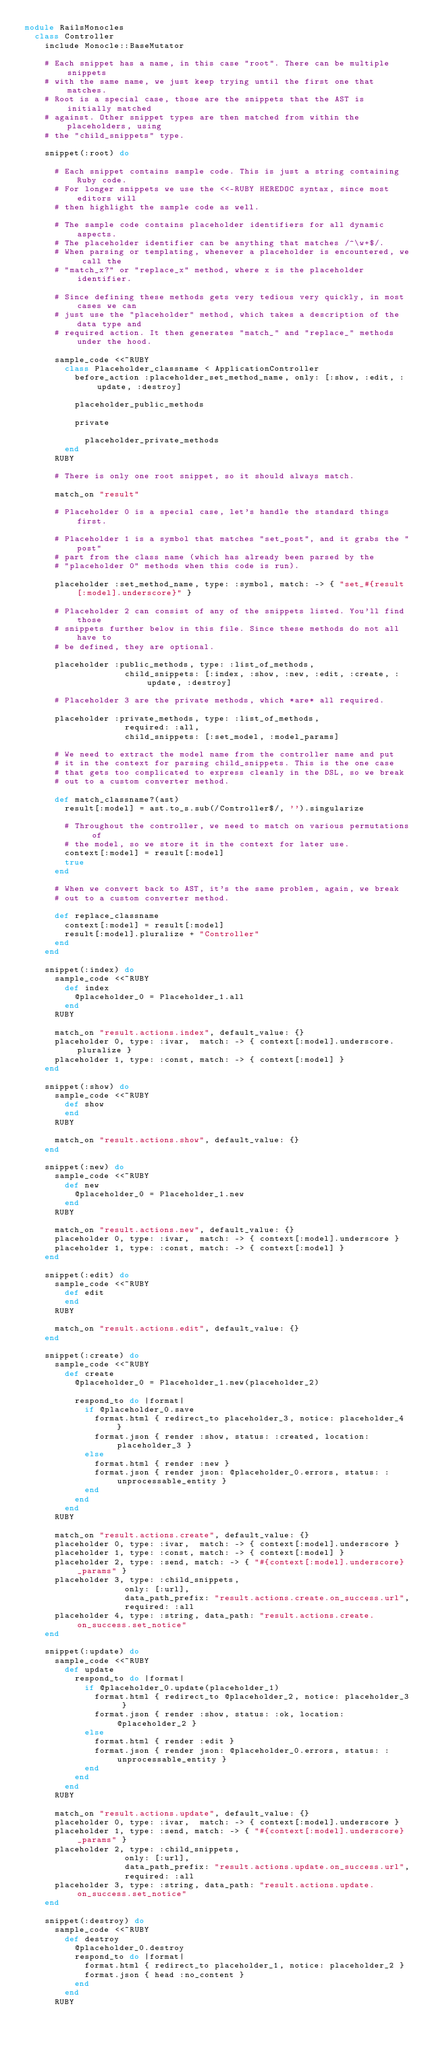<code> <loc_0><loc_0><loc_500><loc_500><_Ruby_>module RailsMonocles
  class Controller
    include Monocle::BaseMutator

    # Each snippet has a name, in this case "root". There can be multiple snippets
    # with the same name, we just keep trying until the first one that matches.
    # Root is a special case, those are the snippets that the AST is initially matched
    # against. Other snippet types are then matched from within the placeholders, using
    # the "child_snippets" type.

    snippet(:root) do

      # Each snippet contains sample code. This is just a string containing Ruby code.
      # For longer snippets we use the <<-RUBY HEREDOC syntax, since most editors will
      # then highlight the sample code as well.

      # The sample code contains placeholder identifiers for all dynamic aspects.
      # The placeholder identifier can be anything that matches /^\w+$/.
      # When parsing or templating, whenever a placeholder is encountered, we call the
      # "match_x?" or "replace_x" method, where x is the placeholder identifier.

      # Since defining these methods gets very tedious very quickly, in most cases we can
      # just use the "placeholder" method, which takes a description of the data type and
      # required action. It then generates "match_" and "replace_" methods under the hood.

      sample_code <<~RUBY
        class Placeholder_classname < ApplicationController
          before_action :placeholder_set_method_name, only: [:show, :edit, :update, :destroy]

          placeholder_public_methods

          private

            placeholder_private_methods
        end
      RUBY

      # There is only one root snippet, so it should always match.

      match_on "result"

      # Placeholder 0 is a special case, let's handle the standard things first.

      # Placeholder 1 is a symbol that matches "set_post", and it grabs the "post"
      # part from the class name (which has already been parsed by the
      # "placeholder 0" methods when this code is run).

      placeholder :set_method_name, type: :symbol, match: -> { "set_#{result[:model].underscore}" }

      # Placeholder 2 can consist of any of the snippets listed. You'll find those
      # snippets further below in this file. Since these methods do not all have to
      # be defined, they are optional.

      placeholder :public_methods, type: :list_of_methods,
                    child_snippets: [:index, :show, :new, :edit, :create, :update, :destroy]

      # Placeholder 3 are the private methods, which *are* all required.

      placeholder :private_methods, type: :list_of_methods,
                    required: :all,
                    child_snippets: [:set_model, :model_params]

      # We need to extract the model name from the controller name and put
      # it in the context for parsing child_snippets. This is the one case
      # that gets too complicated to express cleanly in the DSL, so we break
      # out to a custom converter method.

      def match_classname?(ast)
        result[:model] = ast.to_s.sub(/Controller$/, '').singularize

        # Throughout the controller, we need to match on various permutations of
        # the model, so we store it in the context for later use.
        context[:model] = result[:model]
        true
      end

      # When we convert back to AST, it's the same problem, again, we break
      # out to a custom converter method.

      def replace_classname
        context[:model] = result[:model]
        result[:model].pluralize + "Controller"
      end
    end

    snippet(:index) do
      sample_code <<~RUBY
        def index
          @placeholder_0 = Placeholder_1.all
        end
      RUBY

      match_on "result.actions.index", default_value: {}
      placeholder 0, type: :ivar,  match: -> { context[:model].underscore.pluralize }
      placeholder 1, type: :const, match: -> { context[:model] }
    end

    snippet(:show) do
      sample_code <<~RUBY
        def show
        end
      RUBY

      match_on "result.actions.show", default_value: {}
    end

    snippet(:new) do
      sample_code <<~RUBY
        def new
          @placeholder_0 = Placeholder_1.new
        end
      RUBY

      match_on "result.actions.new", default_value: {}
      placeholder 0, type: :ivar,  match: -> { context[:model].underscore }
      placeholder 1, type: :const, match: -> { context[:model] }
    end

    snippet(:edit) do
      sample_code <<~RUBY
        def edit
        end
      RUBY

      match_on "result.actions.edit", default_value: {}
    end

    snippet(:create) do
      sample_code <<~RUBY
        def create
          @placeholder_0 = Placeholder_1.new(placeholder_2)

          respond_to do |format|
            if @placeholder_0.save
              format.html { redirect_to placeholder_3, notice: placeholder_4 }
              format.json { render :show, status: :created, location: placeholder_3 }
            else
              format.html { render :new }
              format.json { render json: @placeholder_0.errors, status: :unprocessable_entity }
            end
          end
        end
      RUBY

      match_on "result.actions.create", default_value: {}
      placeholder 0, type: :ivar,  match: -> { context[:model].underscore }
      placeholder 1, type: :const, match: -> { context[:model] }
      placeholder 2, type: :send, match: -> { "#{context[:model].underscore}_params" }
      placeholder 3, type: :child_snippets,
                    only: [:url],
                    data_path_prefix: "result.actions.create.on_success.url",
                    required: :all
      placeholder 4, type: :string, data_path: "result.actions.create.on_success.set_notice"
    end

    snippet(:update) do
      sample_code <<~RUBY
        def update
          respond_to do |format|
            if @placeholder_0.update(placeholder_1)
              format.html { redirect_to @placeholder_2, notice: placeholder_3 }
              format.json { render :show, status: :ok, location: @placeholder_2 }
            else
              format.html { render :edit }
              format.json { render json: @placeholder_0.errors, status: :unprocessable_entity }
            end
          end
        end
      RUBY

      match_on "result.actions.update", default_value: {}
      placeholder 0, type: :ivar,  match: -> { context[:model].underscore }
      placeholder 1, type: :send, match: -> { "#{context[:model].underscore}_params" }
      placeholder 2, type: :child_snippets,
                    only: [:url],
                    data_path_prefix: "result.actions.update.on_success.url",
                    required: :all
      placeholder 3, type: :string, data_path: "result.actions.update.on_success.set_notice"
    end

    snippet(:destroy) do
      sample_code <<~RUBY
        def destroy
          @placeholder_0.destroy
          respond_to do |format|
            format.html { redirect_to placeholder_1, notice: placeholder_2 }
            format.json { head :no_content }
          end
        end
      RUBY
</code> 